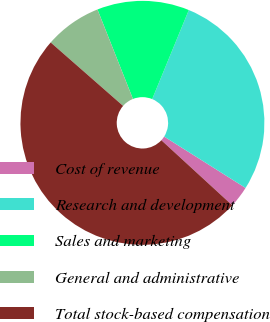Convert chart. <chart><loc_0><loc_0><loc_500><loc_500><pie_chart><fcel>Cost of revenue<fcel>Research and development<fcel>Sales and marketing<fcel>General and administrative<fcel>Total stock-based compensation<nl><fcel>2.86%<fcel>27.75%<fcel>12.22%<fcel>7.54%<fcel>49.63%<nl></chart> 